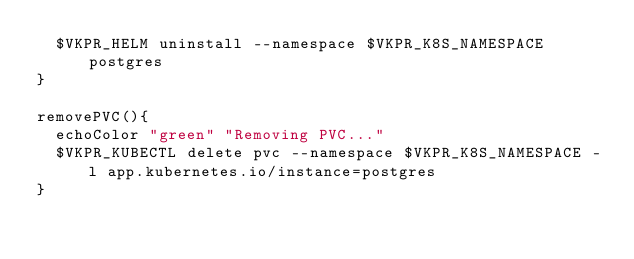<code> <loc_0><loc_0><loc_500><loc_500><_Bash_>  $VKPR_HELM uninstall --namespace $VKPR_K8S_NAMESPACE postgres
}

removePVC(){
  echoColor "green" "Removing PVC..."
  $VKPR_KUBECTL delete pvc --namespace $VKPR_K8S_NAMESPACE -l app.kubernetes.io/instance=postgres
}</code> 